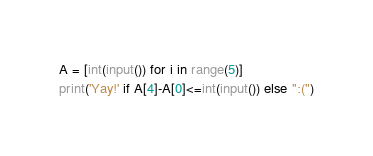Convert code to text. <code><loc_0><loc_0><loc_500><loc_500><_Python_>A = [int(input()) for i in range(5)]
print('Yay!' if A[4]-A[0]<=int(input()) else ":(")</code> 